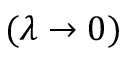<formula> <loc_0><loc_0><loc_500><loc_500>( \lambda \to 0 )</formula> 